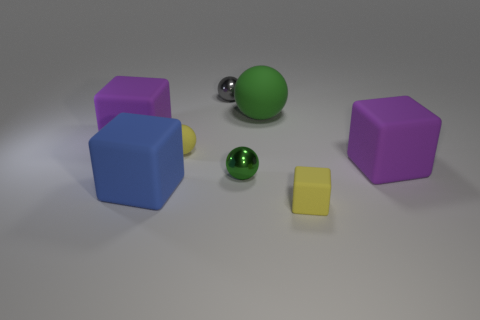There is a small thing that is both right of the small gray metal thing and behind the yellow matte block; what material is it?
Give a very brief answer. Metal. Do the big block on the right side of the big green thing and the gray object have the same material?
Your answer should be compact. No. What is the material of the big green sphere?
Your response must be concise. Rubber. How big is the purple block that is on the right side of the gray shiny sphere?
Provide a short and direct response. Large. There is a large block behind the yellow rubber thing to the left of the green metallic thing; is there a big matte object behind it?
Provide a short and direct response. Yes. There is a large rubber block that is right of the small yellow ball; is its color the same as the tiny rubber cube?
Your response must be concise. No. How many cylinders are either green metal things or large blue things?
Make the answer very short. 0. There is a yellow thing that is left of the small rubber object to the right of the green metal sphere; what shape is it?
Give a very brief answer. Sphere. How big is the purple matte object left of the green ball that is behind the big purple matte block that is to the right of the large blue thing?
Keep it short and to the point. Large. Do the yellow matte sphere and the blue block have the same size?
Provide a short and direct response. No. 